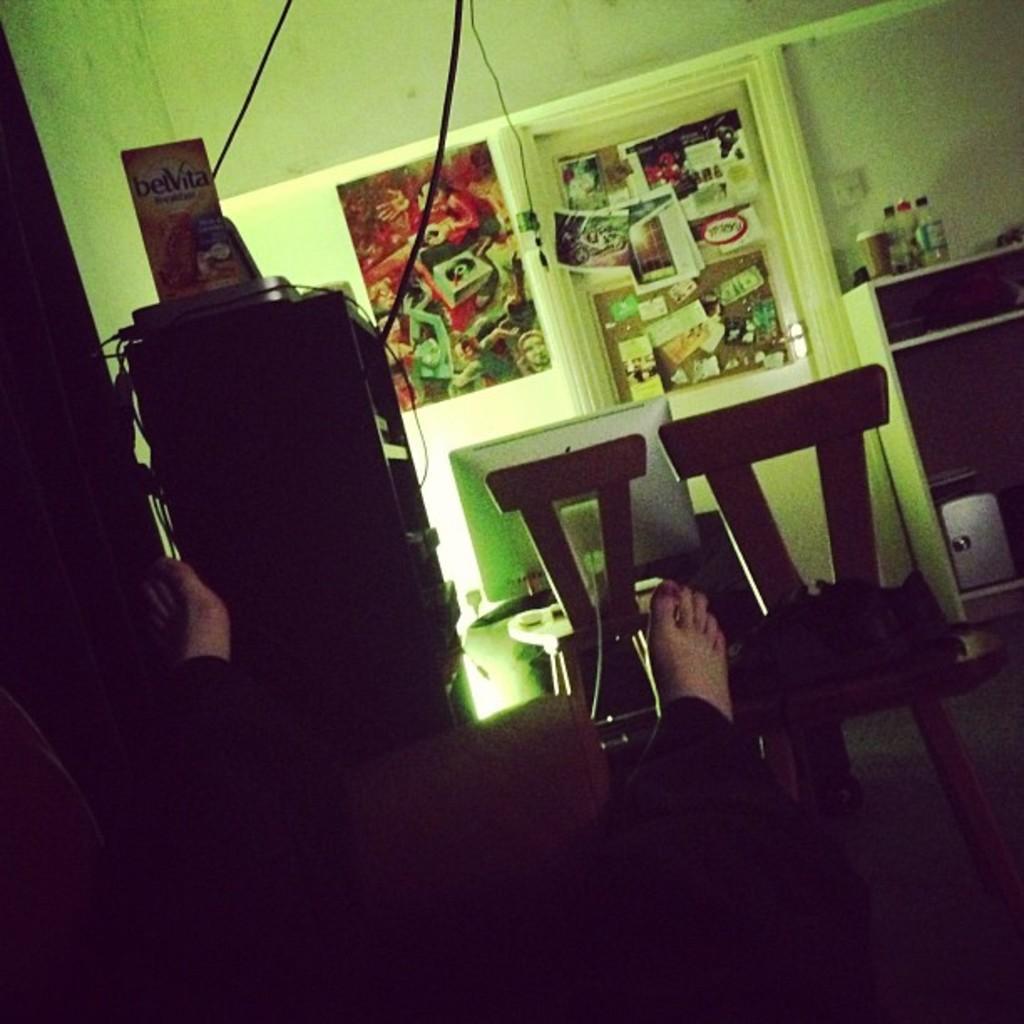In one or two sentences, can you explain what this image depicts? This image is taken inside a room. In the middle of the image a man is sitting on sofa and stretching his legs. At the background there is a wall with frames on it. In the right side of the image there is a cupboard and there were things on it and there are few empty chairs in this room. 